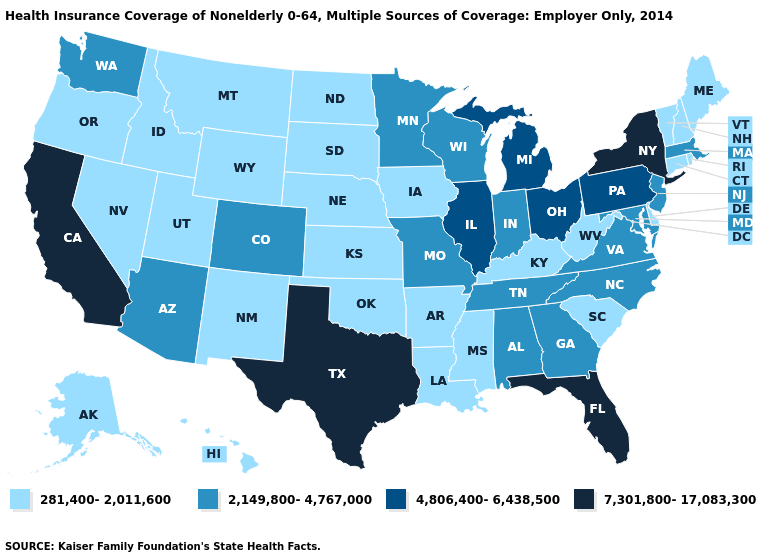Which states hav the highest value in the Northeast?
Concise answer only. New York. Name the states that have a value in the range 281,400-2,011,600?
Give a very brief answer. Alaska, Arkansas, Connecticut, Delaware, Hawaii, Idaho, Iowa, Kansas, Kentucky, Louisiana, Maine, Mississippi, Montana, Nebraska, Nevada, New Hampshire, New Mexico, North Dakota, Oklahoma, Oregon, Rhode Island, South Carolina, South Dakota, Utah, Vermont, West Virginia, Wyoming. What is the lowest value in the USA?
Write a very short answer. 281,400-2,011,600. Does Texas have the highest value in the USA?
Quick response, please. Yes. What is the value of Iowa?
Quick response, please. 281,400-2,011,600. Name the states that have a value in the range 2,149,800-4,767,000?
Answer briefly. Alabama, Arizona, Colorado, Georgia, Indiana, Maryland, Massachusetts, Minnesota, Missouri, New Jersey, North Carolina, Tennessee, Virginia, Washington, Wisconsin. What is the value of Idaho?
Answer briefly. 281,400-2,011,600. What is the highest value in the West ?
Give a very brief answer. 7,301,800-17,083,300. Which states have the highest value in the USA?
Quick response, please. California, Florida, New York, Texas. Name the states that have a value in the range 2,149,800-4,767,000?
Quick response, please. Alabama, Arizona, Colorado, Georgia, Indiana, Maryland, Massachusetts, Minnesota, Missouri, New Jersey, North Carolina, Tennessee, Virginia, Washington, Wisconsin. Which states hav the highest value in the MidWest?
Give a very brief answer. Illinois, Michigan, Ohio. What is the lowest value in the USA?
Quick response, please. 281,400-2,011,600. Name the states that have a value in the range 7,301,800-17,083,300?
Give a very brief answer. California, Florida, New York, Texas. Among the states that border Minnesota , which have the lowest value?
Quick response, please. Iowa, North Dakota, South Dakota. 